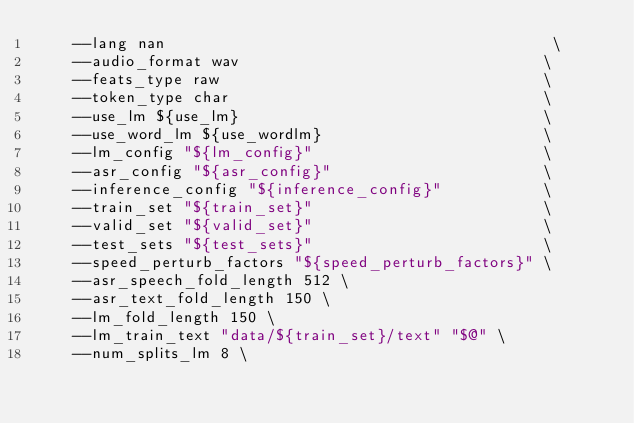Convert code to text. <code><loc_0><loc_0><loc_500><loc_500><_Bash_>    --lang nan                                          \
    --audio_format wav                                 \
    --feats_type raw                                   \
    --token_type char                                  \
    --use_lm ${use_lm}                                 \
    --use_word_lm ${use_wordlm}                        \
    --lm_config "${lm_config}"                         \
    --asr_config "${asr_config}"                       \
    --inference_config "${inference_config}"           \
    --train_set "${train_set}"                         \
    --valid_set "${valid_set}"                         \
    --test_sets "${test_sets}"                         \
    --speed_perturb_factors "${speed_perturb_factors}" \
    --asr_speech_fold_length 512 \
    --asr_text_fold_length 150 \
    --lm_fold_length 150 \
    --lm_train_text "data/${train_set}/text" "$@" \
    --num_splits_lm 8 \</code> 